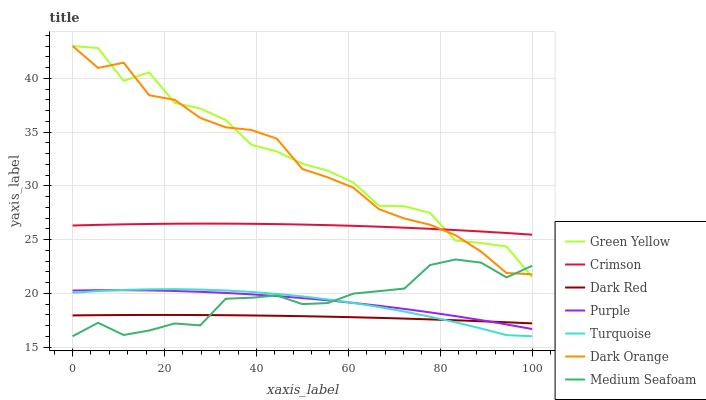Does Dark Red have the minimum area under the curve?
Answer yes or no. Yes. Does Green Yellow have the maximum area under the curve?
Answer yes or no. Yes. Does Turquoise have the minimum area under the curve?
Answer yes or no. No. Does Turquoise have the maximum area under the curve?
Answer yes or no. No. Is Dark Red the smoothest?
Answer yes or no. Yes. Is Green Yellow the roughest?
Answer yes or no. Yes. Is Turquoise the smoothest?
Answer yes or no. No. Is Turquoise the roughest?
Answer yes or no. No. Does Turquoise have the lowest value?
Answer yes or no. Yes. Does Purple have the lowest value?
Answer yes or no. No. Does Green Yellow have the highest value?
Answer yes or no. Yes. Does Turquoise have the highest value?
Answer yes or no. No. Is Turquoise less than Dark Orange?
Answer yes or no. Yes. Is Green Yellow greater than Turquoise?
Answer yes or no. Yes. Does Turquoise intersect Purple?
Answer yes or no. Yes. Is Turquoise less than Purple?
Answer yes or no. No. Is Turquoise greater than Purple?
Answer yes or no. No. Does Turquoise intersect Dark Orange?
Answer yes or no. No. 